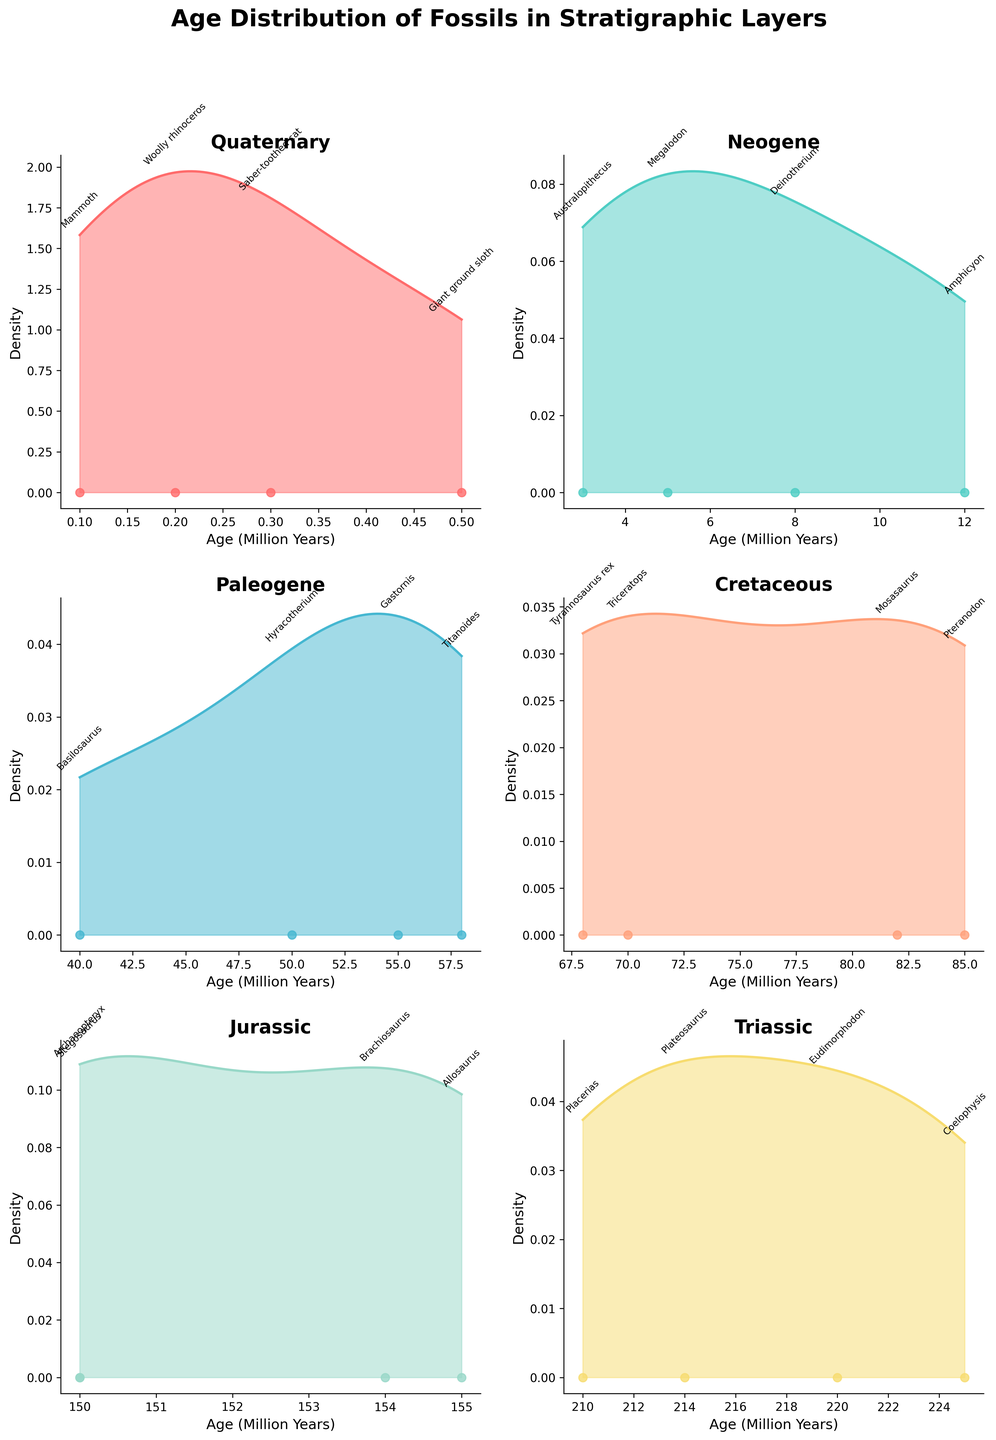What is the title of the figure? The title of the figure is shown at the top in bold and larger font. It reads "Age Distribution of Fossils in Stratigraphic Layers."
Answer: Age Distribution of Fossils in Stratigraphic Layers How many stratigraphic layers are represented in the figure? The figure consists of 6 subplots, each representing a different stratigraphic layer. These layers are Quaternary, Neogene, Paleogene, Cretaceous, Jurassic, and Triassic.
Answer: 6 Which stratigraphic layer has the oldest fossil displayed? In the subplot for the Triassic layer, the oldest fossil is displayed at around 225 million years. By comparing the maximum age for each layer, the Triassic layer has the fossil Coelophysis, aged 225 million years, which is the oldest among all layers.
Answer: Triassic What are the ages of fossils in the Quaternary layer? The Quaternary layer's subplot shows age data points annotated with fossil names. The ages, in million years, are 0.1, 0.2, 0.3, and 0.5 as seen next to Mammoth, Woolly rhinoceros, Saber-toothed cat, and Giant ground sloth, respectively.
Answer: 0.1, 0.2, 0.3, 0.5 Which fossil in the Jurassic layer is represented at around 150 million years? The subplot for the Jurassic layer shows an annotation near the 150-million-year mark. The fossil named Archaeopteryx is represented at this age.
Answer: Archaeopteryx Compare the age ranges of fossils in the Neogene and Paleogene layers. Which range is broader? In the Neogene layer subplot, the ages range from 3 to 12 million years (a span of 9 million years). In the Paleogene layer subplot, the ages range from 40 to 58 million years (a span of 18 million years). The Paleogene layer has a broader age range.
Answer: Paleogene Identify the fossil with the youngest age in the entire figure. By examining all subplots, the youngest fossil is Mammoth located in the Quaternary layer with an age of 0.1 million years, as annotated in its subplot.
Answer: Mammoth Which stratigraphic layer contains the most recent fossils? The Quaternary layer contains the most recent fossils, with ages of 0.1, 0.2, 0.3, and 0.5 million years as annotated in its subplot.
Answer: Quaternary How is the density of fossils distributed in the Cretaceous layer? In the Cretaceous layer subplot, the density plot shows several peaks, indicating a distribution with multiple concentrations. The density is higher around the ages of 70 million years and 85 million years.
Answer: Multiple peaks around 70 and 85 million years 